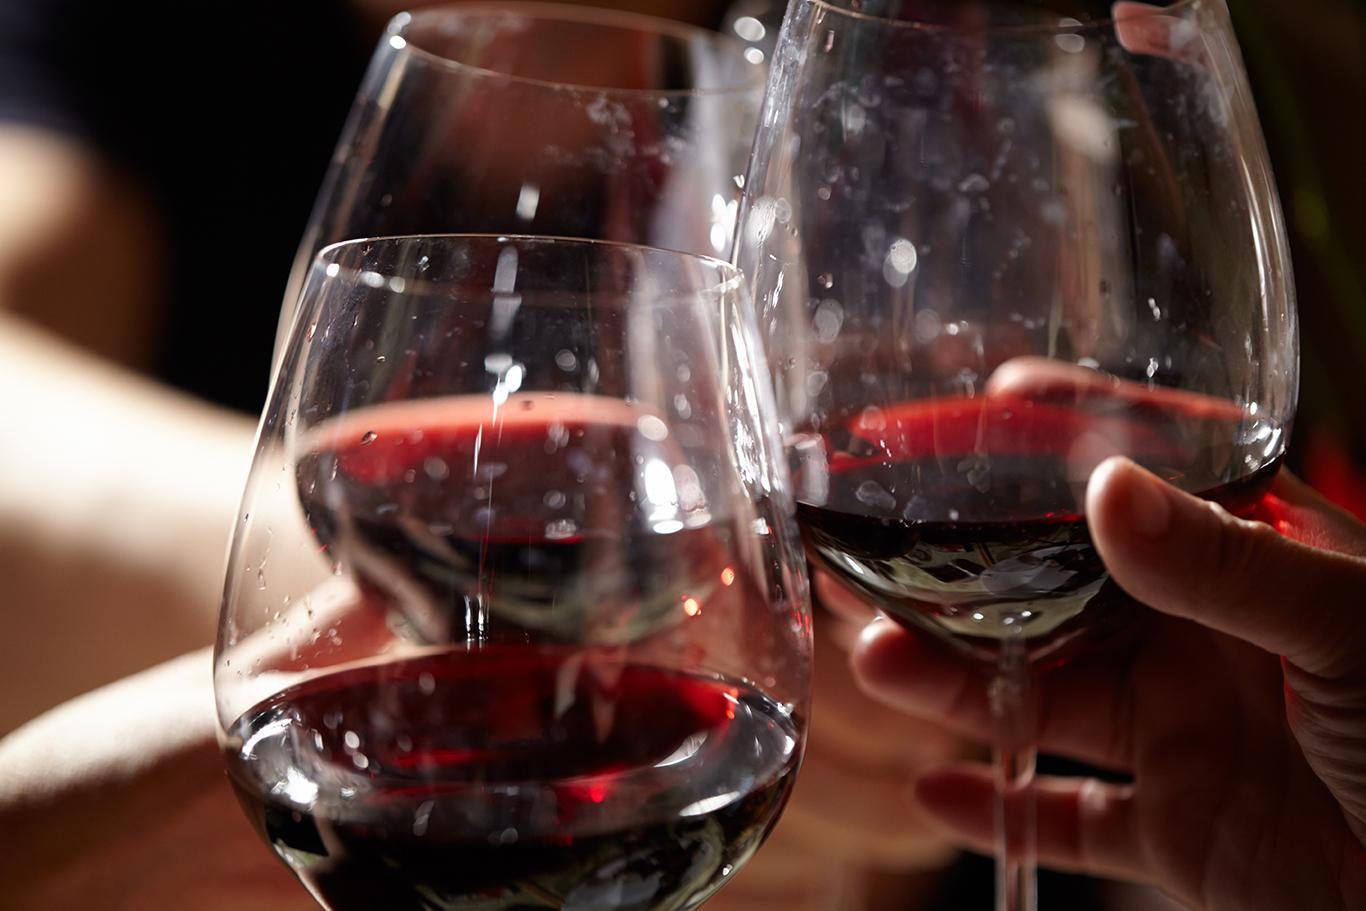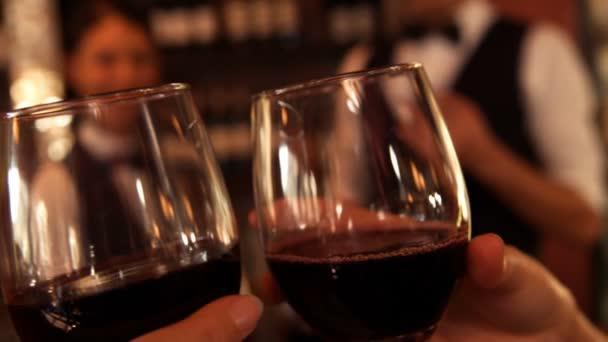The first image is the image on the left, the second image is the image on the right. For the images shown, is this caption "There are human hands holding a glass of wine." true? Answer yes or no. Yes. The first image is the image on the left, the second image is the image on the right. Assess this claim about the two images: "Exactly one image shows hands holding stemmed glasses of wine.". Correct or not? Answer yes or no. No. 